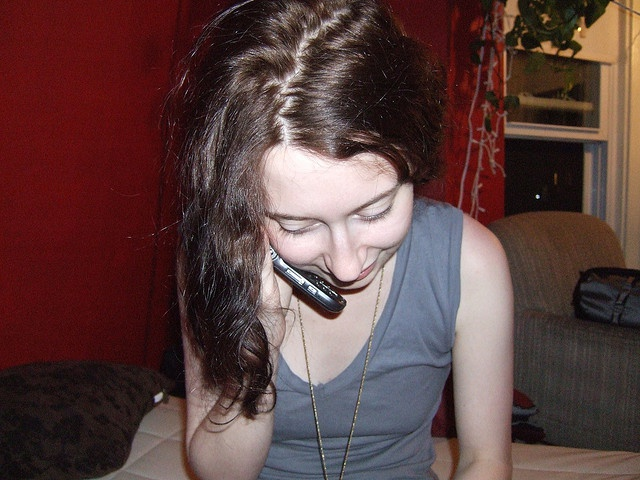Describe the objects in this image and their specific colors. I can see people in maroon, black, gray, lightgray, and darkgray tones, couch in maroon, black, and gray tones, chair in maroon, black, and gray tones, bed in maroon, gray, and brown tones, and backpack in maroon and black tones in this image. 